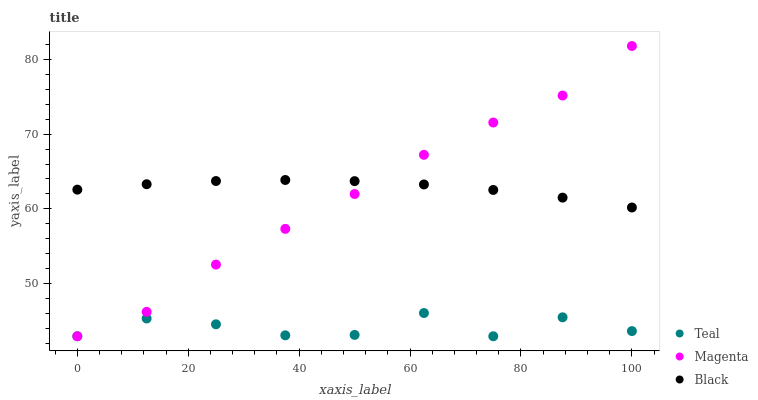Does Teal have the minimum area under the curve?
Answer yes or no. Yes. Does Black have the maximum area under the curve?
Answer yes or no. Yes. Does Black have the minimum area under the curve?
Answer yes or no. No. Does Teal have the maximum area under the curve?
Answer yes or no. No. Is Black the smoothest?
Answer yes or no. Yes. Is Teal the roughest?
Answer yes or no. Yes. Is Teal the smoothest?
Answer yes or no. No. Is Black the roughest?
Answer yes or no. No. Does Magenta have the lowest value?
Answer yes or no. Yes. Does Black have the lowest value?
Answer yes or no. No. Does Magenta have the highest value?
Answer yes or no. Yes. Does Black have the highest value?
Answer yes or no. No. Is Teal less than Black?
Answer yes or no. Yes. Is Black greater than Teal?
Answer yes or no. Yes. Does Black intersect Magenta?
Answer yes or no. Yes. Is Black less than Magenta?
Answer yes or no. No. Is Black greater than Magenta?
Answer yes or no. No. Does Teal intersect Black?
Answer yes or no. No. 